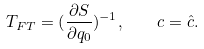Convert formula to latex. <formula><loc_0><loc_0><loc_500><loc_500>T _ { F T } = ( \frac { \partial S } { \partial q _ { 0 } } ) ^ { - 1 } , \quad c = \hat { c } .</formula> 